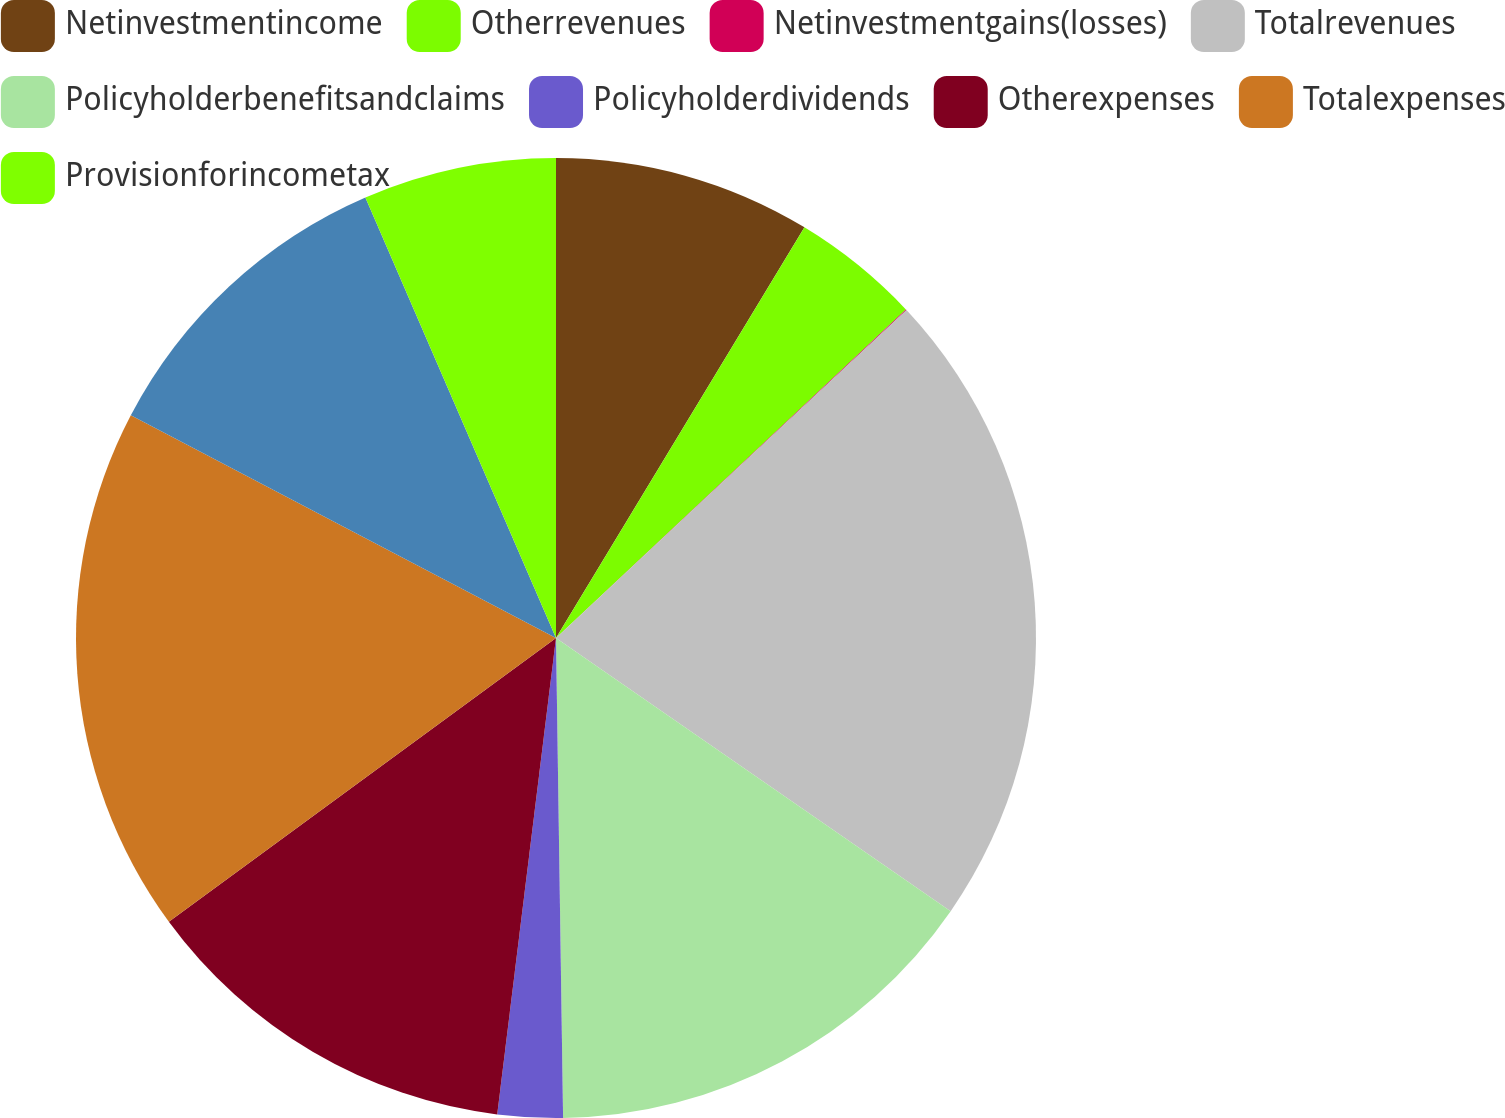Convert chart. <chart><loc_0><loc_0><loc_500><loc_500><pie_chart><fcel>Netinvestmentincome<fcel>Otherrevenues<fcel>Netinvestmentgains(losses)<fcel>Totalrevenues<fcel>Policyholderbenefitsandclaims<fcel>Policyholderdividends<fcel>Otherexpenses<fcel>Totalexpenses<fcel>Unnamed: 8<fcel>Provisionforincometax<nl><fcel>8.66%<fcel>4.34%<fcel>0.03%<fcel>21.61%<fcel>15.13%<fcel>2.19%<fcel>12.98%<fcel>17.75%<fcel>10.82%<fcel>6.5%<nl></chart> 